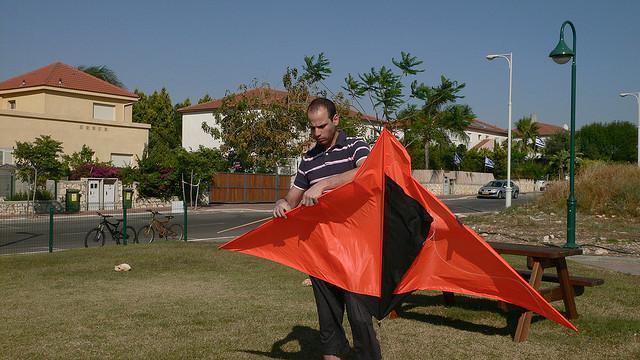How many bikes do you see?
Give a very brief answer. 2. 